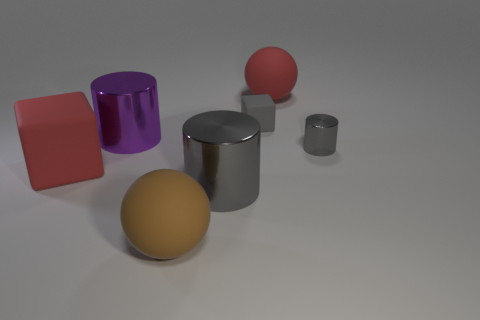How many small rubber things have the same color as the small cylinder?
Your answer should be very brief. 1. How big is the brown sphere?
Offer a very short reply. Large. Does the brown object have the same shape as the large metal object that is to the right of the brown thing?
Your response must be concise. No. What is the color of the small cube that is made of the same material as the red ball?
Keep it short and to the point. Gray. How big is the gray cylinder right of the large gray cylinder?
Keep it short and to the point. Small. Are there fewer small rubber blocks in front of the big red cube than tiny red balls?
Your answer should be compact. No. Does the small metallic cylinder have the same color as the small block?
Give a very brief answer. Yes. Are there any other things that have the same shape as the small gray matte object?
Your answer should be very brief. Yes. Are there fewer small purple objects than red cubes?
Offer a very short reply. Yes. There is a big matte ball that is on the left side of the matte sphere that is to the right of the big brown thing; what is its color?
Keep it short and to the point. Brown. 